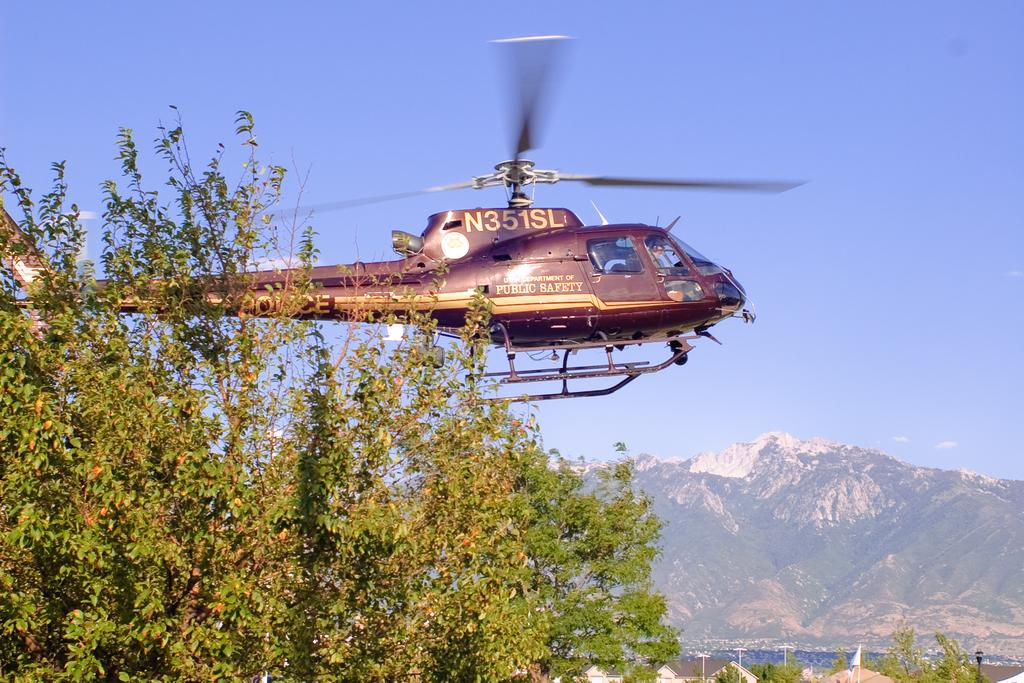<image>
Summarize the visual content of the image. a helicopter with the letters 'n351sl' on the top of it 